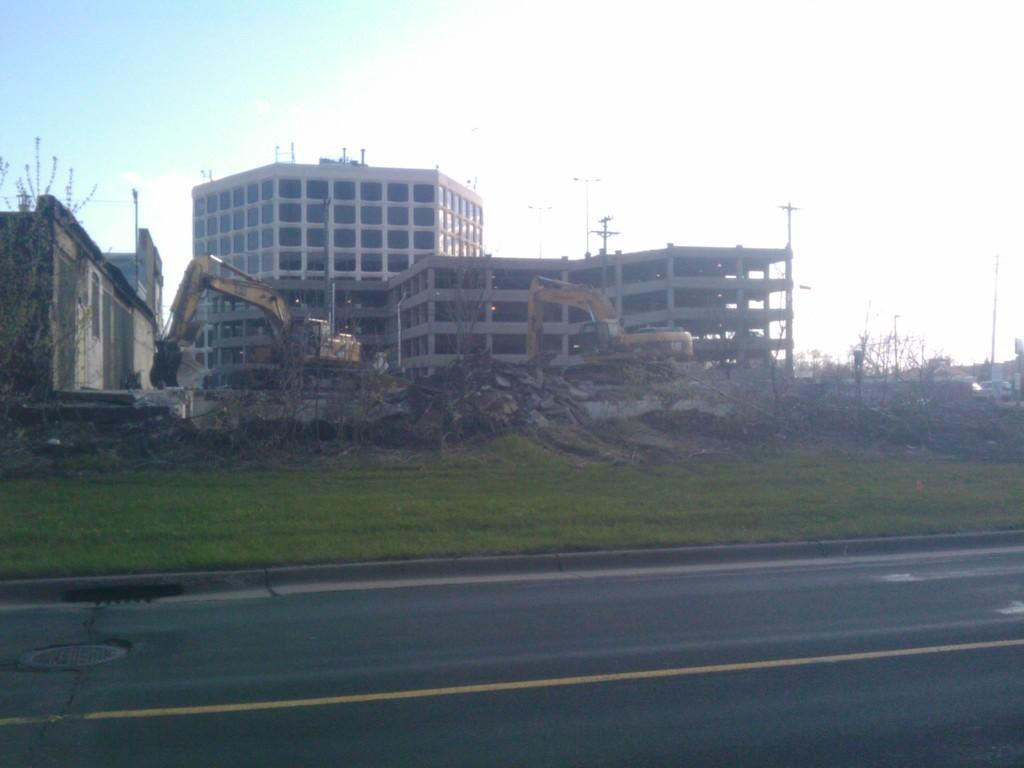What is located in the center of the image? There are buildings in the center of the image. What else can be seen in the image besides the buildings? There are proclaimers and grass visible in the image. What is at the bottom of the image? There is a road at the bottom of the image. What type of finger can be seen holding the eggnog in the image? There is no finger or eggnog present in the image. 